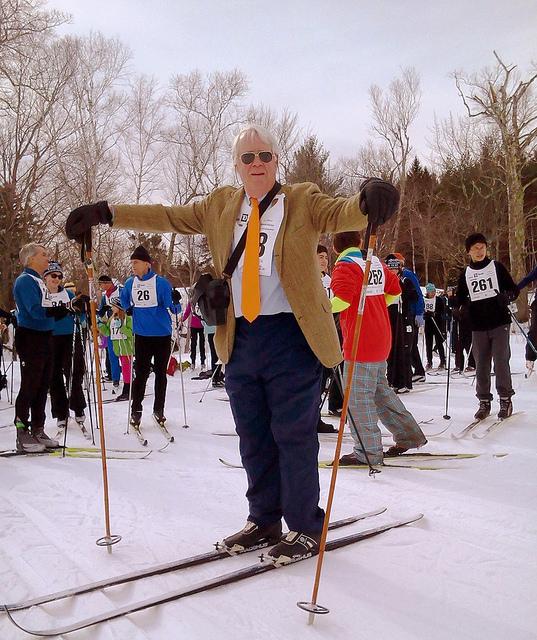What number is the furthest right person wearing in this photo?
Answer briefly. 261. What is on the man's face?
Concise answer only. Sunglasses. Is this a contest?
Answer briefly. Yes. 